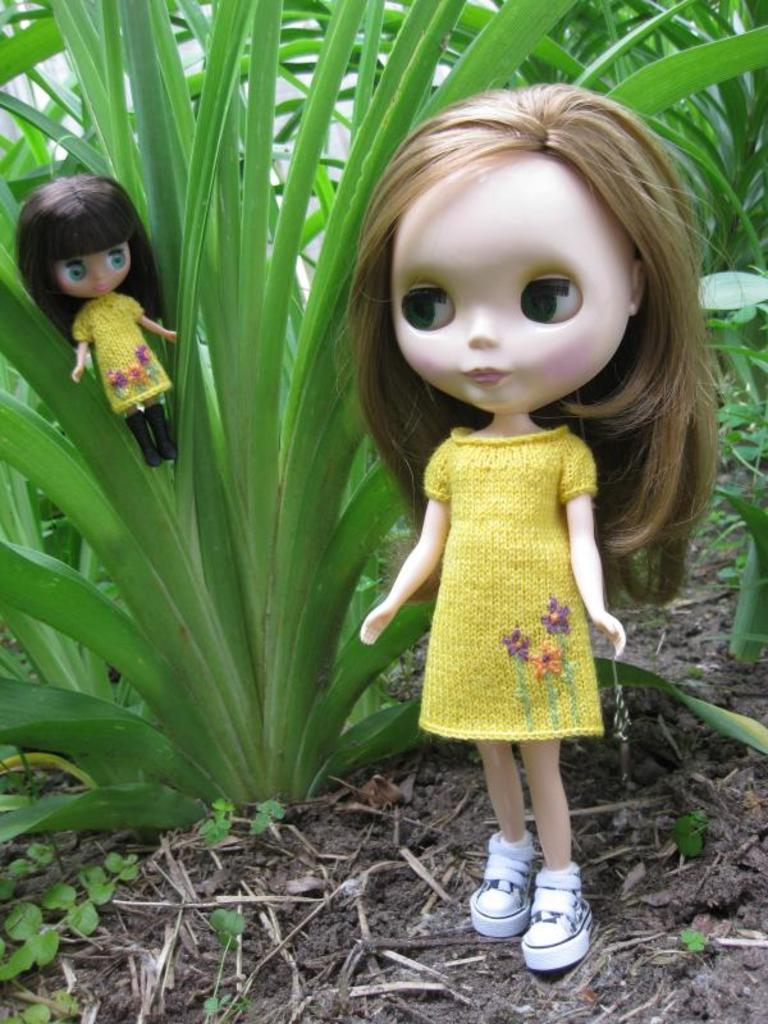What is the main subject in the front of the image? There is a doll in the front of the image. What can be seen at the bottom of the image? Soil and twigs are visible at the bottom of the image. Is there another doll in the image? Yes, there is a doll on the left side of the image. What type of vegetation can be seen in the background of the image? There are plants in the background of the image. What type of road can be seen in the background of the image? There is no road visible in the background of the image; it features plants instead. What color is the dress the doll is wearing in the image? The facts provided do not mention a dress or any clothing on the doll, so we cannot determine the color of a dress. 